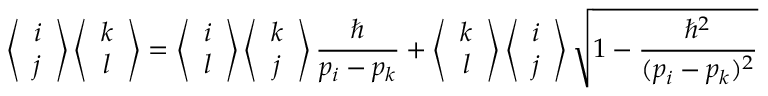<formula> <loc_0><loc_0><loc_500><loc_500>\left \langle \begin{array} { c c } { i } \\ { j } \end{array} \right \rangle \left \langle \begin{array} { c c } { k } \\ { l } \end{array} \right \rangle = \left \langle \begin{array} { c c } { i } \\ { l } \end{array} \right \rangle \left \langle \begin{array} { c c } { k } \\ { j } \end{array} \right \rangle \frac { } { p _ { i } - p _ { k } } + \left \langle \begin{array} { c c } { k } \\ { l } \end{array} \right \rangle \left \langle \begin{array} { c c } { i } \\ { j } \end{array} \right \rangle \sqrt { 1 - \frac { \hbar { ^ } { 2 } } { ( p _ { i } - p _ { k } ) ^ { 2 } } }</formula> 